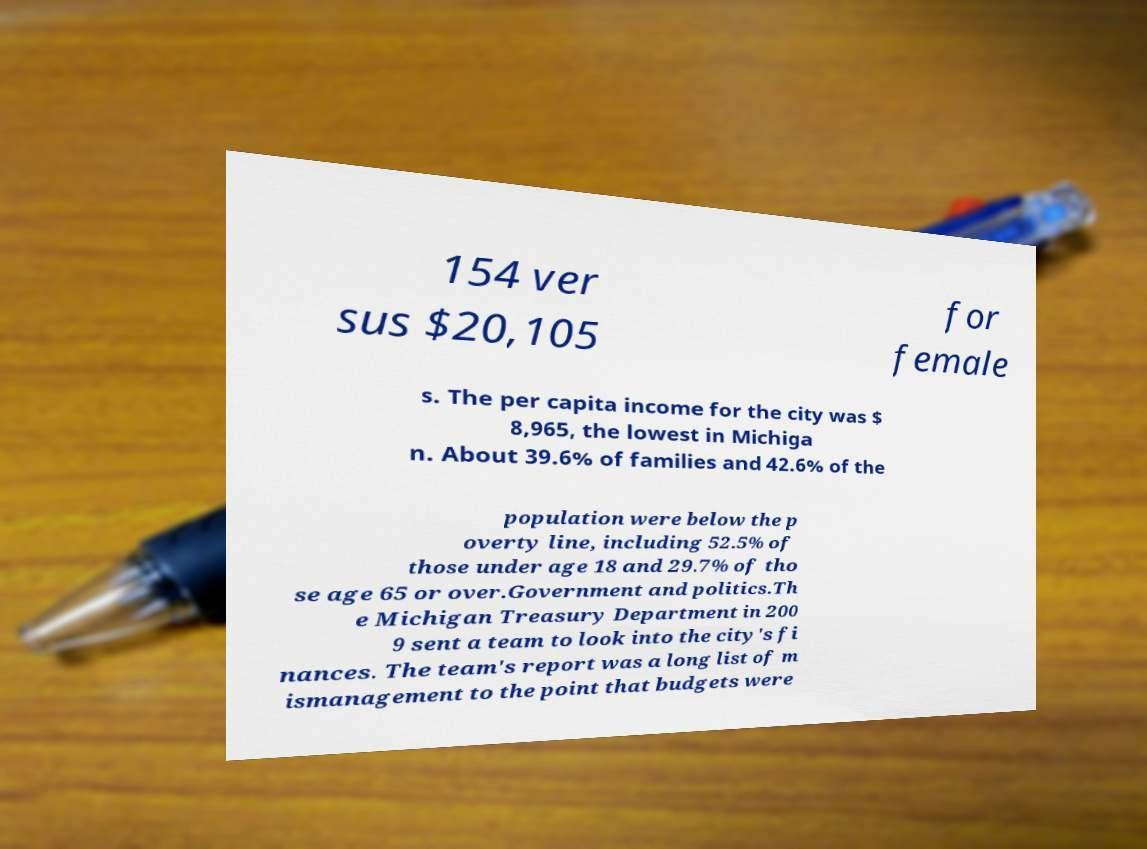Can you read and provide the text displayed in the image?This photo seems to have some interesting text. Can you extract and type it out for me? 154 ver sus $20,105 for female s. The per capita income for the city was $ 8,965, the lowest in Michiga n. About 39.6% of families and 42.6% of the population were below the p overty line, including 52.5% of those under age 18 and 29.7% of tho se age 65 or over.Government and politics.Th e Michigan Treasury Department in 200 9 sent a team to look into the city's fi nances. The team's report was a long list of m ismanagement to the point that budgets were 